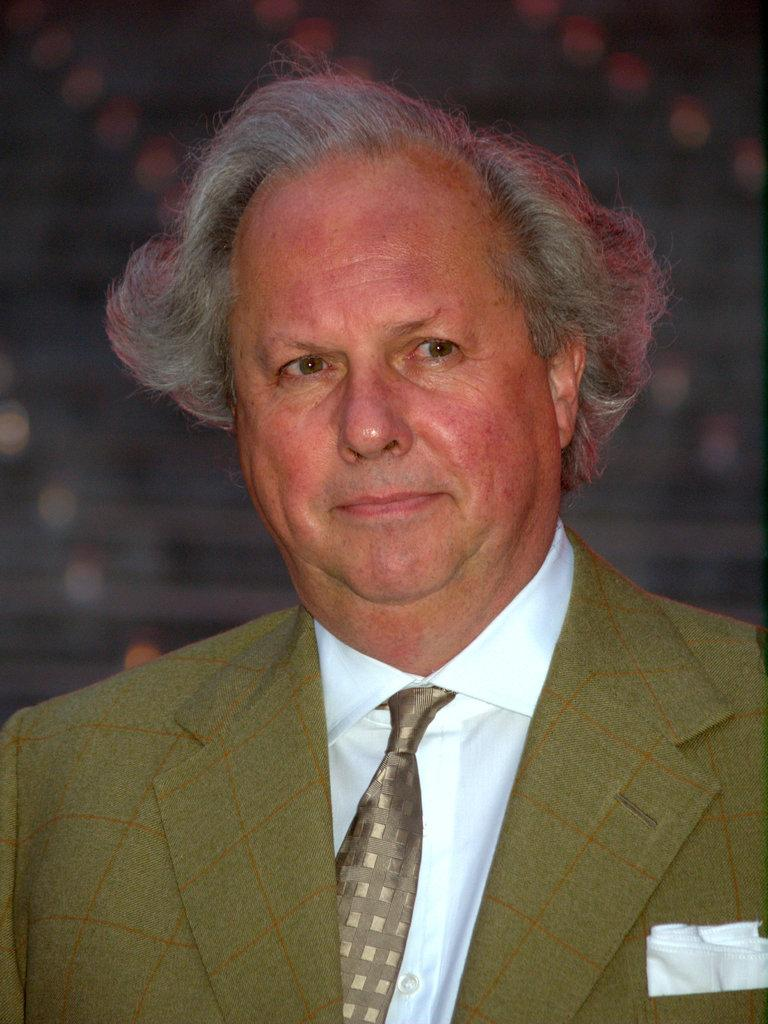What is the main subject of the image? There is a person in the image. What is the person doing in the image? The person is standing in the image. What is the person's facial expression in the image? The person is smiling in the image. What type of attraction can be seen in the background of the image? There is no attraction visible in the image; it only features a person standing and smiling. What season is depicted in the image? The image does not depict a specific season, as there are no seasonal cues present. 